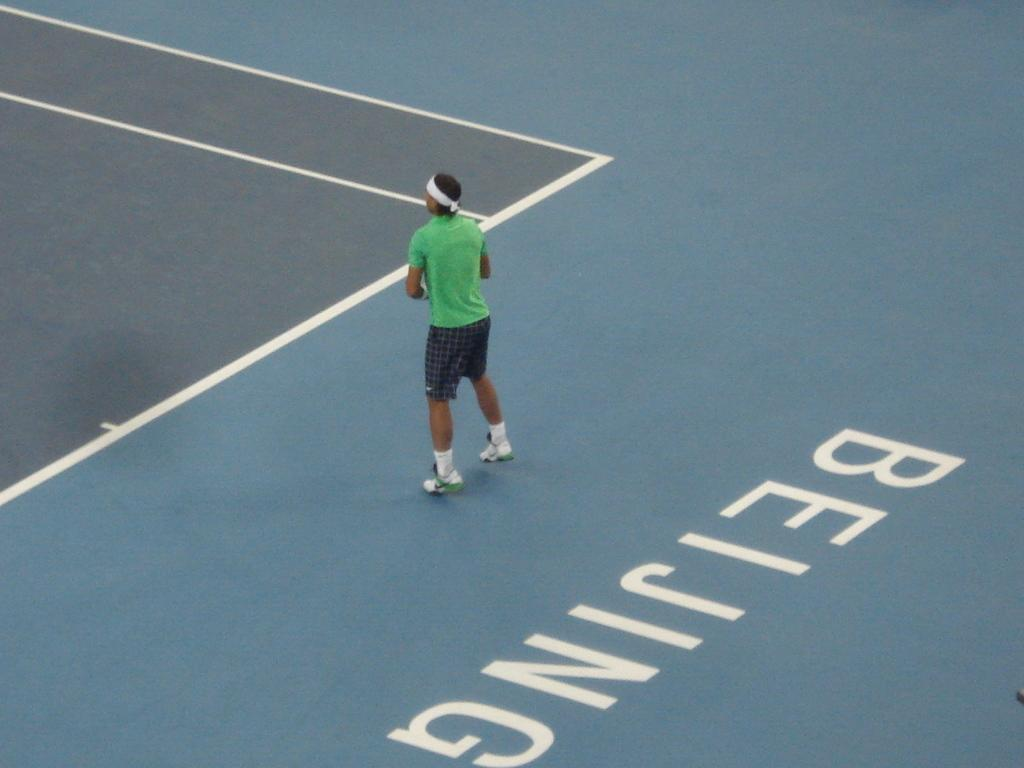What is the person in the image doing? The person is on the floor in the image. What can be seen on the right side of the image? There is text on the floor on the right side of the image. What is located on the left side of the image? There is a court on the left side of the image. How many bridges are visible in the image? There are no bridges present in the image. What type of poison is being used in the image? There is no poison present in the image. 